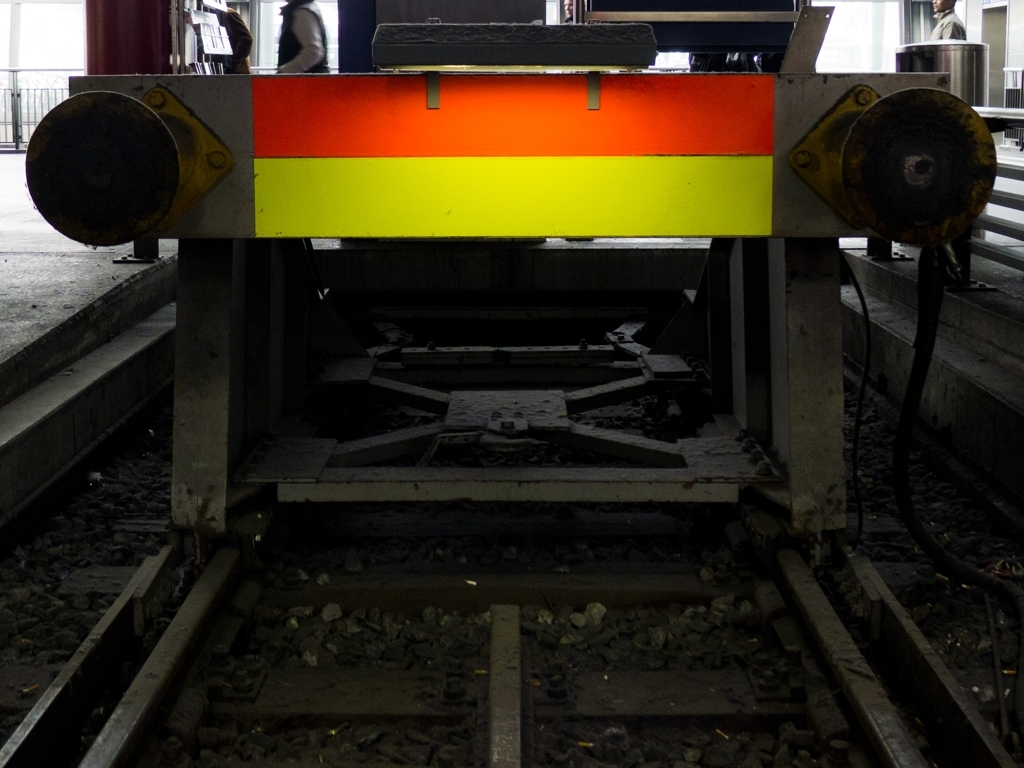Can you tell the time of day or the weather conditions during which this photo was taken? Given the visible aspects of the image, it is difficult to accurately determine the exact time of day or the weather conditions. The dim lighting could suggest it was taken either during early morning, late evening, or even during overcast weather where natural light is minimal. However, the absence of shadows or direct sunlight hints that it is not in the bright midday sun. The enclosed nature of the location may also contribute to the darker ambiance. 